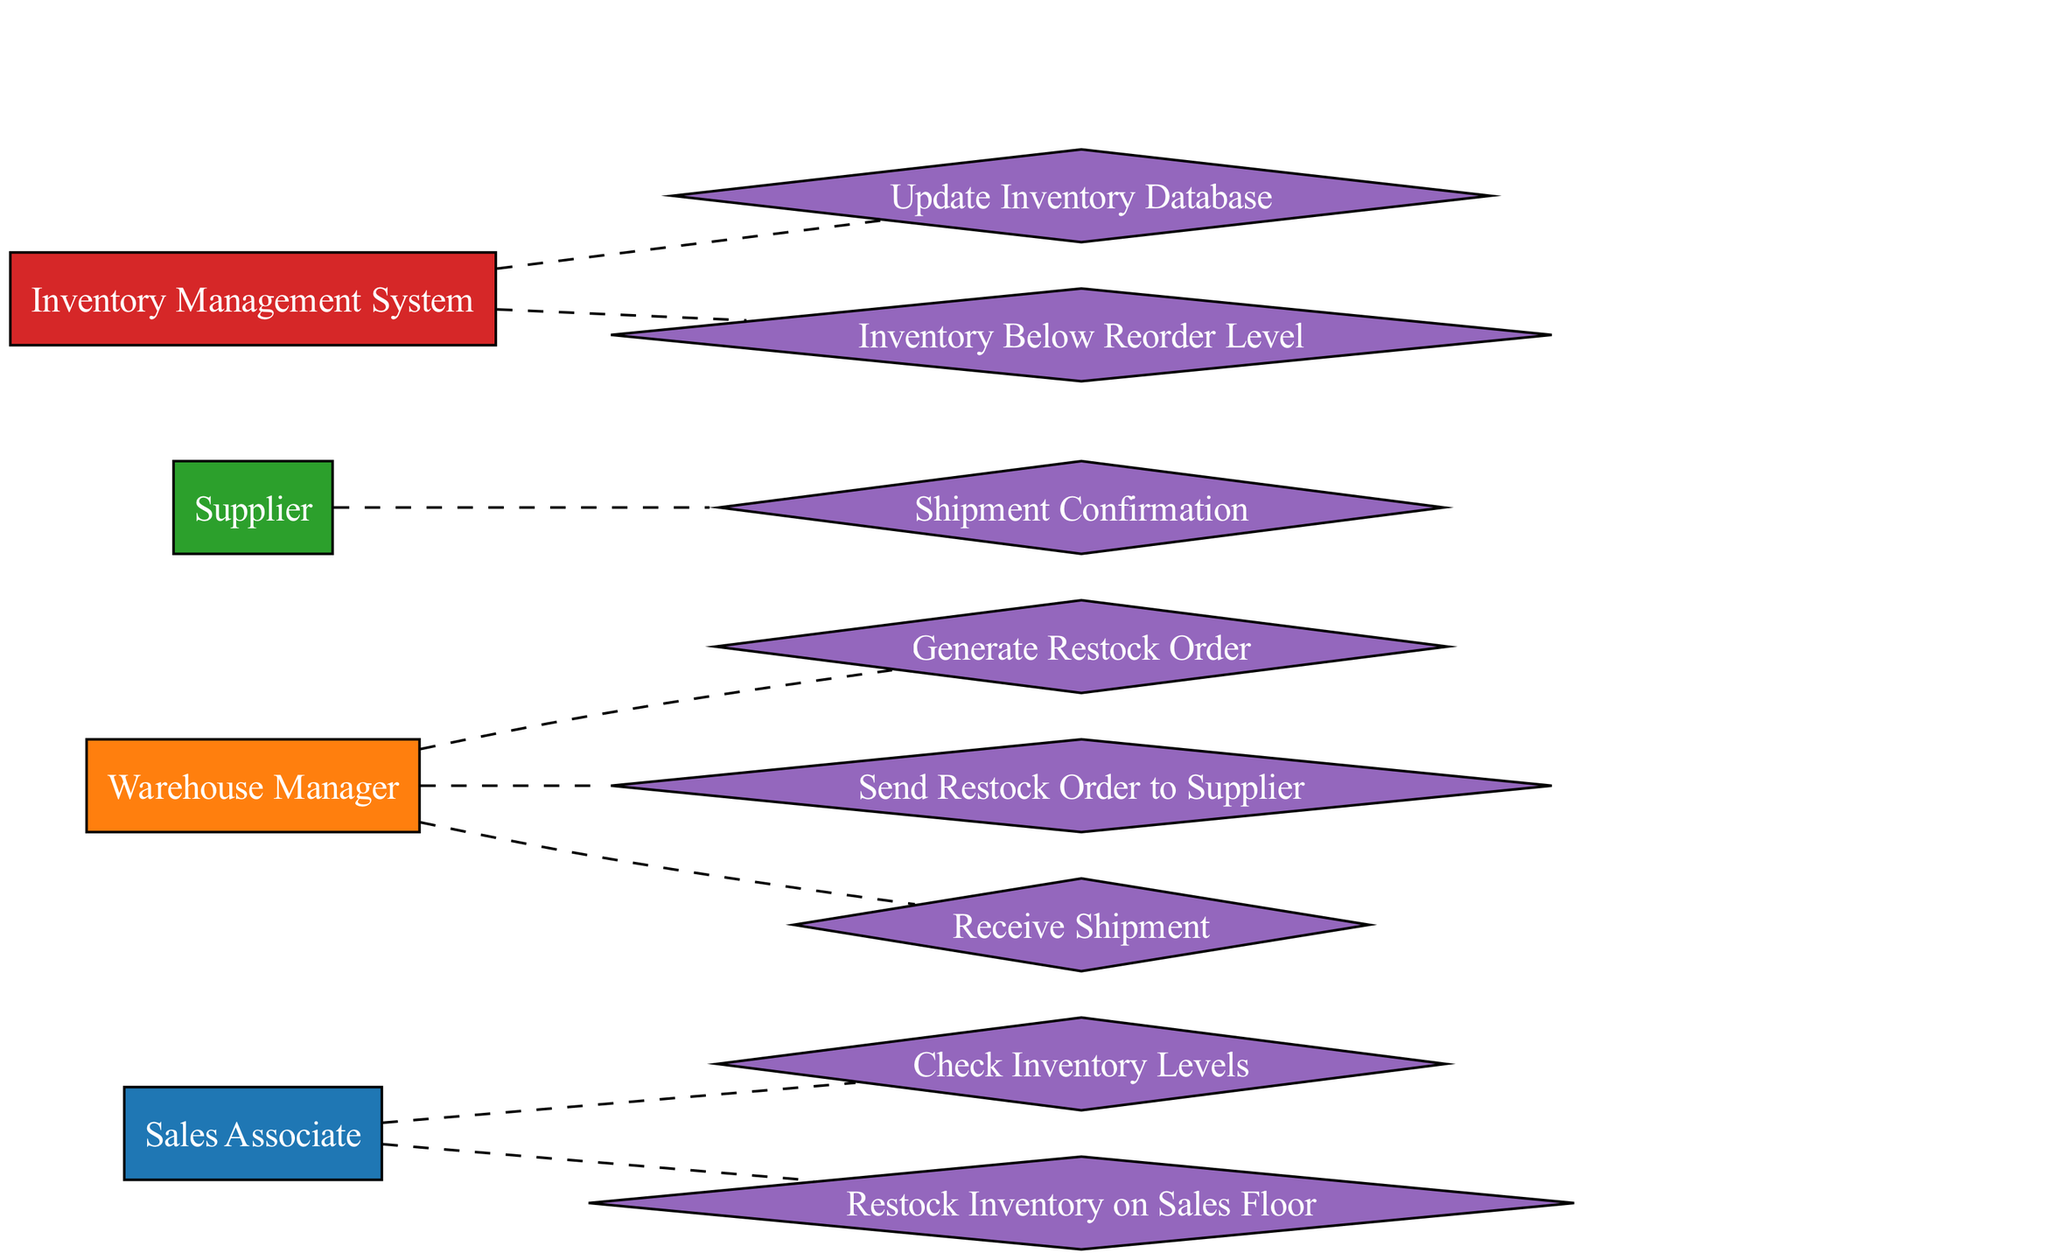What is the first action performed by the Sales Associate? In the diagram, the first action performed by the Sales Associate is to "Check Inventory Levels". It is the initial step in the process, showing the Sales Associate's responsibility in monitoring inventory.
Answer: Check Inventory Levels How many actors are there in the diagram? The diagram includes four actors: Sales Associate, Warehouse Manager, Supplier, and Inventory Management System. By counting these entities, we find the total number of actors involved in the inventory management and restocking flow.
Answer: 4 What is the final action taken in the sequence? The final action in the sequence is "Restock Inventory on Sales Floor," performed by the Sales Associate. This shows the culmination of the entire restocking process.
Answer: Restock Inventory on Sales Floor Which actor generates the restock order? The Warehouse Manager is responsible for generating the restock order. By following the sequence, we notice that this action directly follows the trigger of the inventory being below the reorder level.
Answer: Warehouse Manager What event triggers the generation of a restock order? The event that triggers the generation of a restock order is "Inventory Below Reorder Level," which indicates that the inventory has reached a critical low point, prompting the Warehouse Manager to act.
Answer: Inventory Below Reorder Level Who confirms the shipment? The Supplier confirms the shipment as indicated in the diagram. This step occurs after the Warehouse Manager sends the restock order, highlighting the Supplier's role in the process.
Answer: Supplier How does the Inventory Management System respond to low inventory? The Inventory Management System responds to low inventory by indicating that "Inventory Below Reorder Level". This triggers the sequence of actions to restock inventory effectively.
Answer: Inventory Below Reorder Level What type of relationship exists between the Warehouse Manager and the Supplier? The relationship between the Warehouse Manager and the Supplier is a direct action of sending a "Restock Order" to the Supplier. This interaction indicates a communication flow necessary for inventory replenishment.
Answer: Send Restock Order to Supplier 